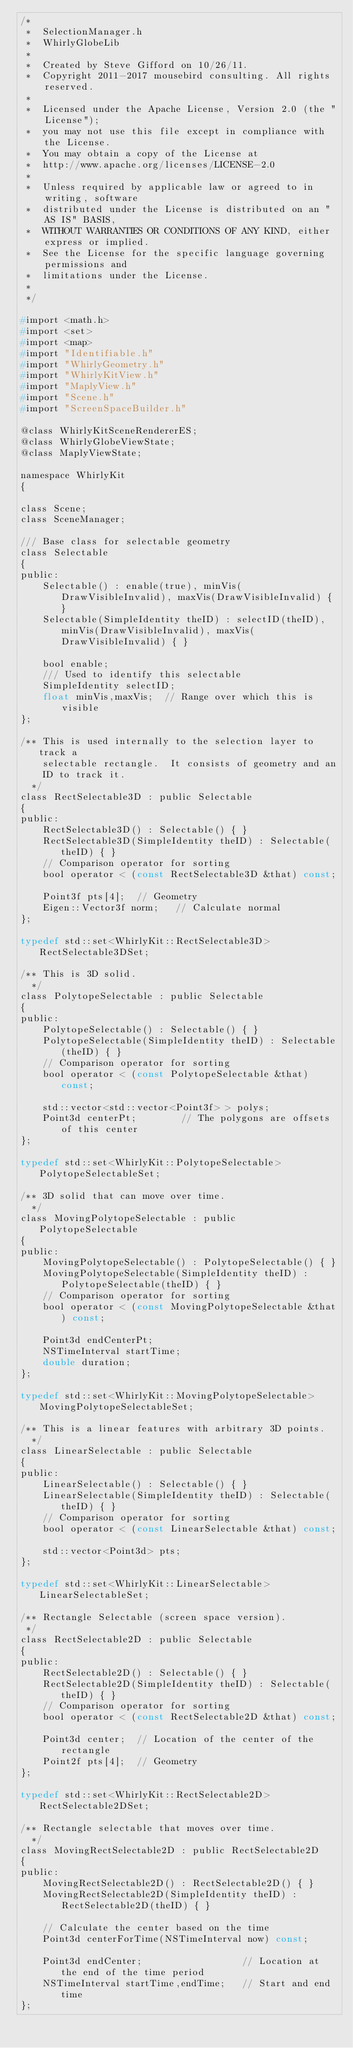<code> <loc_0><loc_0><loc_500><loc_500><_C_>/*
 *  SelectionManager.h
 *  WhirlyGlobeLib
 *
 *  Created by Steve Gifford on 10/26/11.
 *  Copyright 2011-2017 mousebird consulting. All rights reserved.
 *
 *  Licensed under the Apache License, Version 2.0 (the "License");
 *  you may not use this file except in compliance with the License.
 *  You may obtain a copy of the License at
 *  http://www.apache.org/licenses/LICENSE-2.0
 *
 *  Unless required by applicable law or agreed to in writing, software
 *  distributed under the License is distributed on an "AS IS" BASIS,
 *  WITHOUT WARRANTIES OR CONDITIONS OF ANY KIND, either express or implied.
 *  See the License for the specific language governing permissions and
 *  limitations under the License.
 *
 */

#import <math.h>
#import <set>
#import <map>
#import "Identifiable.h"
#import "WhirlyGeometry.h"
#import "WhirlyKitView.h"
#import "MaplyView.h"
#import "Scene.h"
#import "ScreenSpaceBuilder.h"

@class WhirlyKitSceneRendererES;
@class WhirlyGlobeViewState;
@class MaplyViewState;

namespace WhirlyKit
{
    
class Scene;
class SceneManager;

/// Base class for selectable geometry
class Selectable
{
public:
    Selectable() : enable(true), minVis(DrawVisibleInvalid), maxVis(DrawVisibleInvalid) { }
    Selectable(SimpleIdentity theID) : selectID(theID), minVis(DrawVisibleInvalid), maxVis(DrawVisibleInvalid) { }
    
    bool enable;
    /// Used to identify this selectable
    SimpleIdentity selectID;
    float minVis,maxVis;  // Range over which this is visible
};

/** This is used internally to the selection layer to track a
    selectable rectangle.  It consists of geometry and an
    ID to track it.
  */
class RectSelectable3D : public Selectable
{
public:    
    RectSelectable3D() : Selectable() { }
    RectSelectable3D(SimpleIdentity theID) : Selectable(theID) { }
    // Comparison operator for sorting
    bool operator < (const RectSelectable3D &that) const;
    
    Point3f pts[4];  // Geometry
    Eigen::Vector3f norm;   // Calculate normal
};

typedef std::set<WhirlyKit::RectSelectable3D> RectSelectable3DSet;

/** This is 3D solid.
  */
class PolytopeSelectable : public Selectable
{
public:
    PolytopeSelectable() : Selectable() { }
    PolytopeSelectable(SimpleIdentity theID) : Selectable(theID) { }
    // Comparison operator for sorting
    bool operator < (const PolytopeSelectable &that) const;
    
    std::vector<std::vector<Point3f> > polys;
    Point3d centerPt;        // The polygons are offsets of this center
};

typedef std::set<WhirlyKit::PolytopeSelectable> PolytopeSelectableSet;
    
/** 3D solid that can move over time.
  */
class MovingPolytopeSelectable : public PolytopeSelectable
{
public:
    MovingPolytopeSelectable() : PolytopeSelectable() { }
    MovingPolytopeSelectable(SimpleIdentity theID) : PolytopeSelectable(theID) { }
    // Comparison operator for sorting
    bool operator < (const MovingPolytopeSelectable &that) const;
    
    Point3d endCenterPt;
    NSTimeInterval startTime;
    double duration;
};
    
typedef std::set<WhirlyKit::MovingPolytopeSelectable> MovingPolytopeSelectableSet;
    
/** This is a linear features with arbitrary 3D points.
  */
class LinearSelectable : public Selectable
{
public:
    LinearSelectable() : Selectable() { }
    LinearSelectable(SimpleIdentity theID) : Selectable(theID) { }
    // Comparison operator for sorting
    bool operator < (const LinearSelectable &that) const;
    
    std::vector<Point3d> pts;
};

typedef std::set<WhirlyKit::LinearSelectable> LinearSelectableSet;

/** Rectangle Selectable (screen space version).
 */
class RectSelectable2D : public Selectable
{
public:
    RectSelectable2D() : Selectable() { }
    RectSelectable2D(SimpleIdentity theID) : Selectable(theID) { }
    // Comparison operator for sorting
    bool operator < (const RectSelectable2D &that) const;
    
    Point3d center;  // Location of the center of the rectangle
    Point2f pts[4];  // Geometry
};

typedef std::set<WhirlyKit::RectSelectable2D> RectSelectable2DSet;

/** Rectangle selectable that moves over time.
  */
class MovingRectSelectable2D : public RectSelectable2D
{
public:
    MovingRectSelectable2D() : RectSelectable2D() { }
    MovingRectSelectable2D(SimpleIdentity theID) : RectSelectable2D(theID) { }
    
    // Calculate the center based on the time
    Point3d centerForTime(NSTimeInterval now) const;
    
    Point3d endCenter;                  // Location at the end of the time period
    NSTimeInterval startTime,endTime;   // Start and end time
};
</code> 